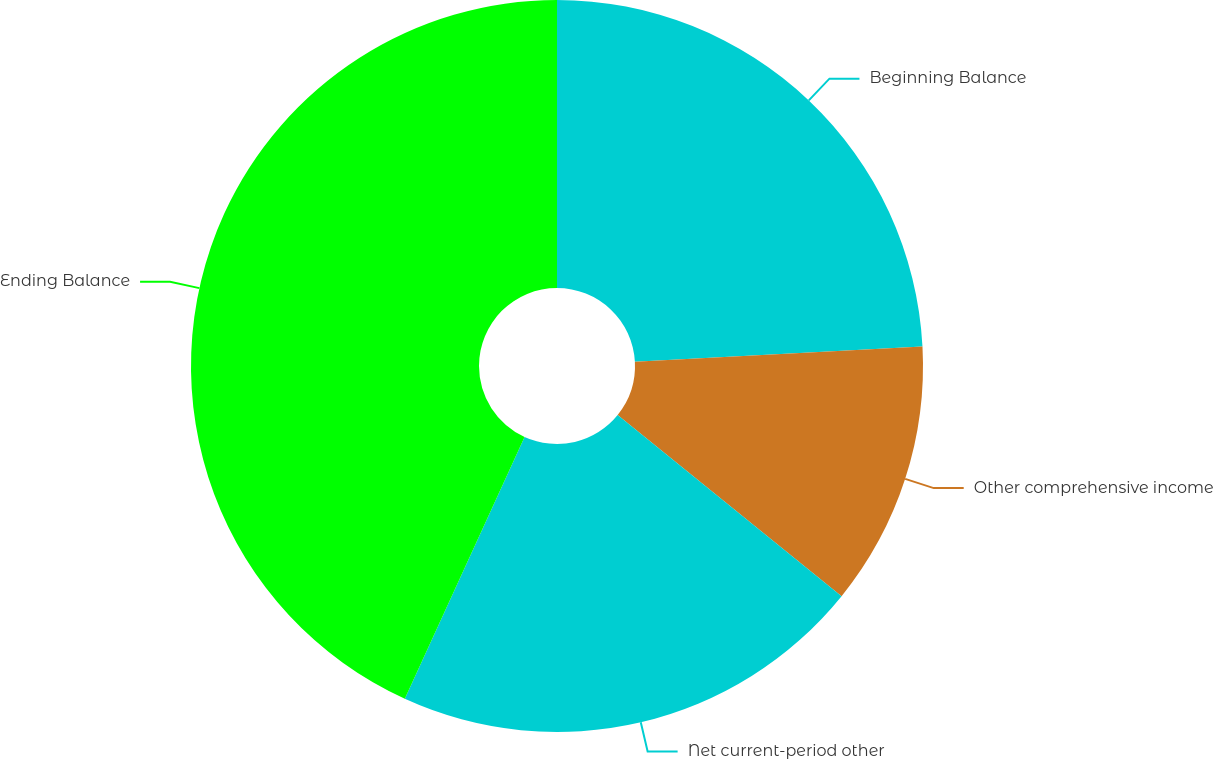<chart> <loc_0><loc_0><loc_500><loc_500><pie_chart><fcel>Beginning Balance<fcel>Other comprehensive income<fcel>Net current-period other<fcel>Ending Balance<nl><fcel>24.15%<fcel>11.67%<fcel>21.0%<fcel>43.17%<nl></chart> 